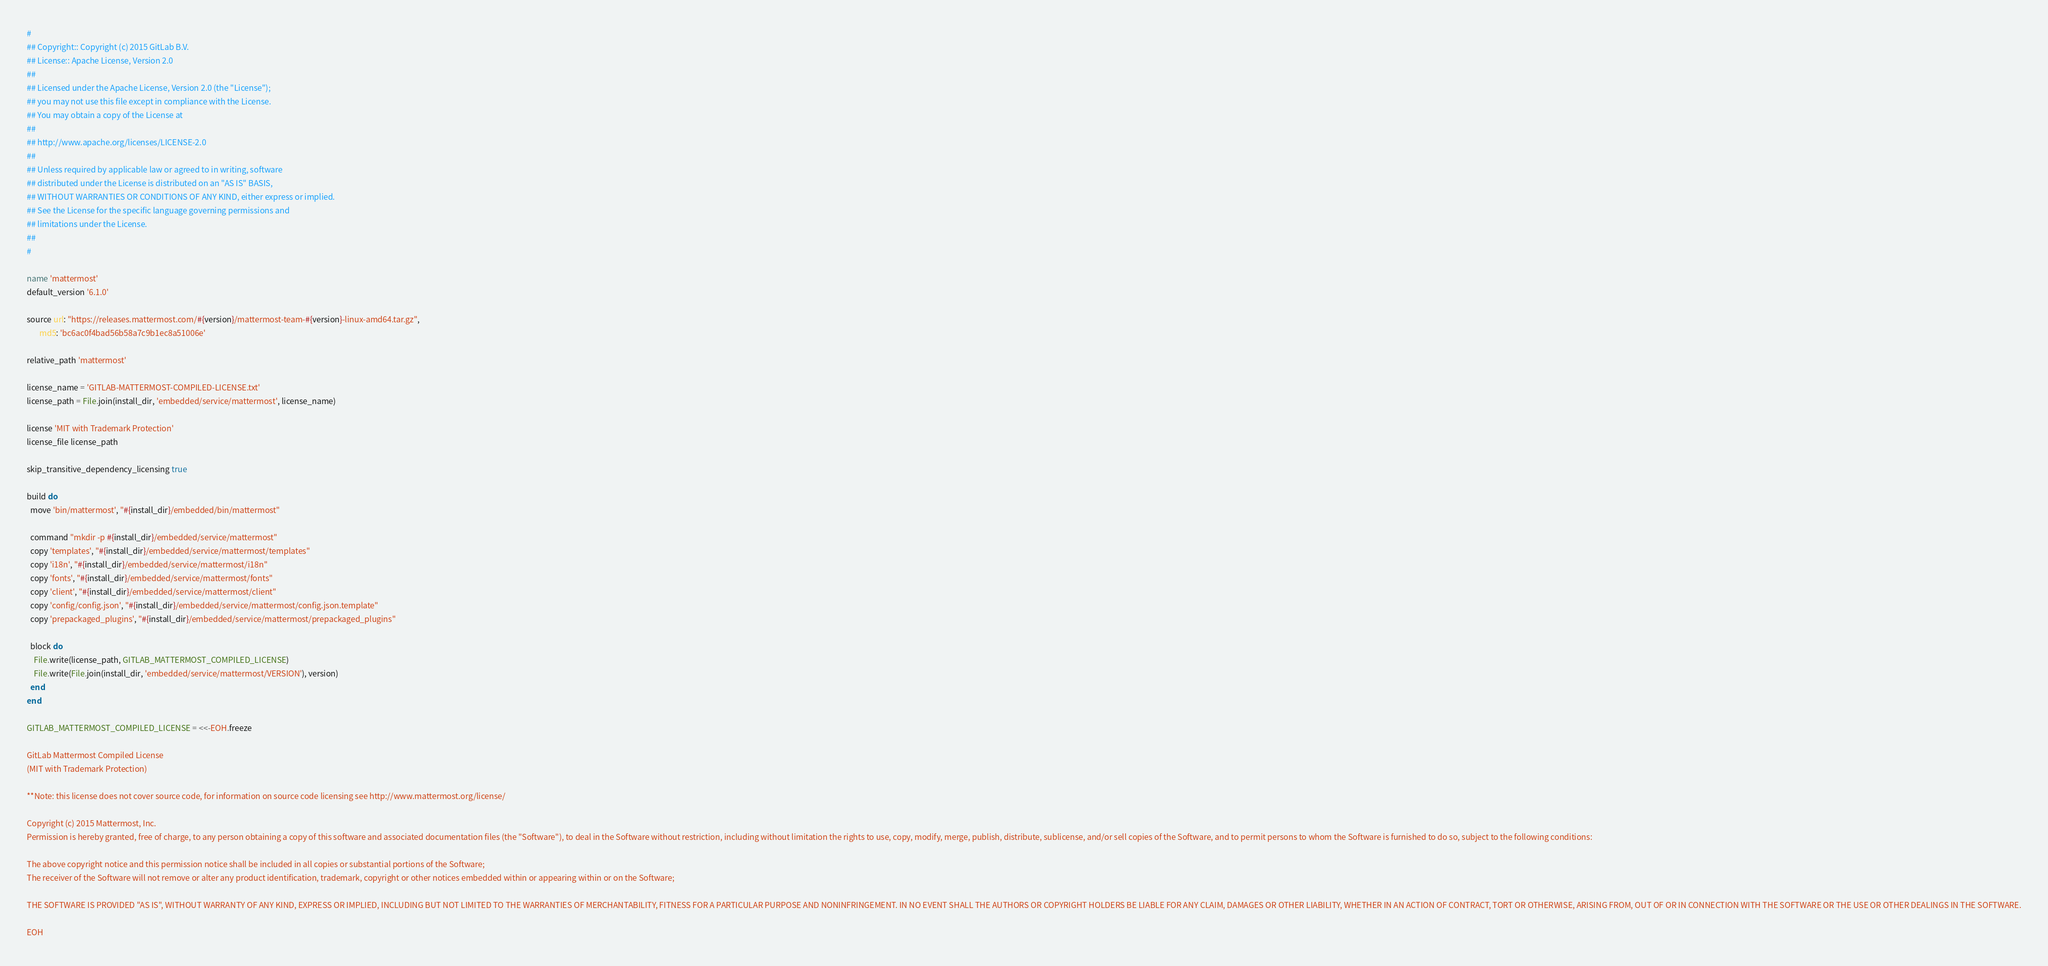<code> <loc_0><loc_0><loc_500><loc_500><_Ruby_>#
## Copyright:: Copyright (c) 2015 GitLab B.V.
## License:: Apache License, Version 2.0
##
## Licensed under the Apache License, Version 2.0 (the "License");
## you may not use this file except in compliance with the License.
## You may obtain a copy of the License at
##
## http://www.apache.org/licenses/LICENSE-2.0
##
## Unless required by applicable law or agreed to in writing, software
## distributed under the License is distributed on an "AS IS" BASIS,
## WITHOUT WARRANTIES OR CONDITIONS OF ANY KIND, either express or implied.
## See the License for the specific language governing permissions and
## limitations under the License.
##
#

name 'mattermost'
default_version '6.1.0'

source url: "https://releases.mattermost.com/#{version}/mattermost-team-#{version}-linux-amd64.tar.gz",
       md5: 'bc6ac0f4bad56b58a7c9b1ec8a51006e'

relative_path 'mattermost'

license_name = 'GITLAB-MATTERMOST-COMPILED-LICENSE.txt'
license_path = File.join(install_dir, 'embedded/service/mattermost', license_name)

license 'MIT with Trademark Protection'
license_file license_path

skip_transitive_dependency_licensing true

build do
  move 'bin/mattermost', "#{install_dir}/embedded/bin/mattermost"

  command "mkdir -p #{install_dir}/embedded/service/mattermost"
  copy 'templates', "#{install_dir}/embedded/service/mattermost/templates"
  copy 'i18n', "#{install_dir}/embedded/service/mattermost/i18n"
  copy 'fonts', "#{install_dir}/embedded/service/mattermost/fonts"
  copy 'client', "#{install_dir}/embedded/service/mattermost/client"
  copy 'config/config.json', "#{install_dir}/embedded/service/mattermost/config.json.template"
  copy 'prepackaged_plugins', "#{install_dir}/embedded/service/mattermost/prepackaged_plugins"

  block do
    File.write(license_path, GITLAB_MATTERMOST_COMPILED_LICENSE)
    File.write(File.join(install_dir, 'embedded/service/mattermost/VERSION'), version)
  end
end

GITLAB_MATTERMOST_COMPILED_LICENSE = <<-EOH.freeze

GitLab Mattermost Compiled License
(MIT with Trademark Protection)

**Note: this license does not cover source code, for information on source code licensing see http://www.mattermost.org/license/

Copyright (c) 2015 Mattermost, Inc.
Permission is hereby granted, free of charge, to any person obtaining a copy of this software and associated documentation files (the "Software"), to deal in the Software without restriction, including without limitation the rights to use, copy, modify, merge, publish, distribute, sublicense, and/or sell copies of the Software, and to permit persons to whom the Software is furnished to do so, subject to the following conditions:

The above copyright notice and this permission notice shall be included in all copies or substantial portions of the Software;
The receiver of the Software will not remove or alter any product identification, trademark, copyright or other notices embedded within or appearing within or on the Software;

THE SOFTWARE IS PROVIDED "AS IS", WITHOUT WARRANTY OF ANY KIND, EXPRESS OR IMPLIED, INCLUDING BUT NOT LIMITED TO THE WARRANTIES OF MERCHANTABILITY, FITNESS FOR A PARTICULAR PURPOSE AND NONINFRINGEMENT. IN NO EVENT SHALL THE AUTHORS OR COPYRIGHT HOLDERS BE LIABLE FOR ANY CLAIM, DAMAGES OR OTHER LIABILITY, WHETHER IN AN ACTION OF CONTRACT, TORT OR OTHERWISE, ARISING FROM, OUT OF OR IN CONNECTION WITH THE SOFTWARE OR THE USE OR OTHER DEALINGS IN THE SOFTWARE.

EOH
</code> 